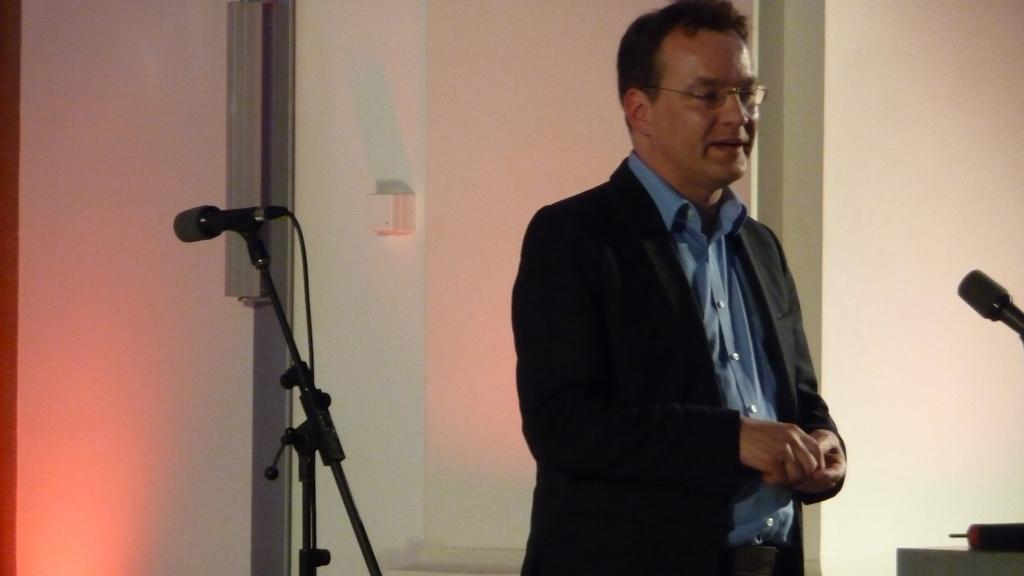What is the main subject of the image? There is a person in the image. What is the person wearing on their upper body? The person is wearing a blue shirt and a black suit. What accessory is the person wearing on their face? The person is wearing spectacles. What is the person's posture in the image? The person is standing. What objects are present on both sides of the image? There are microphones on the right side and the left side of the image. What type of car can be seen driving through the image? There is no car present in the image. What direction is the person pointing in the image? The person is not pointing in any direction in the image. 